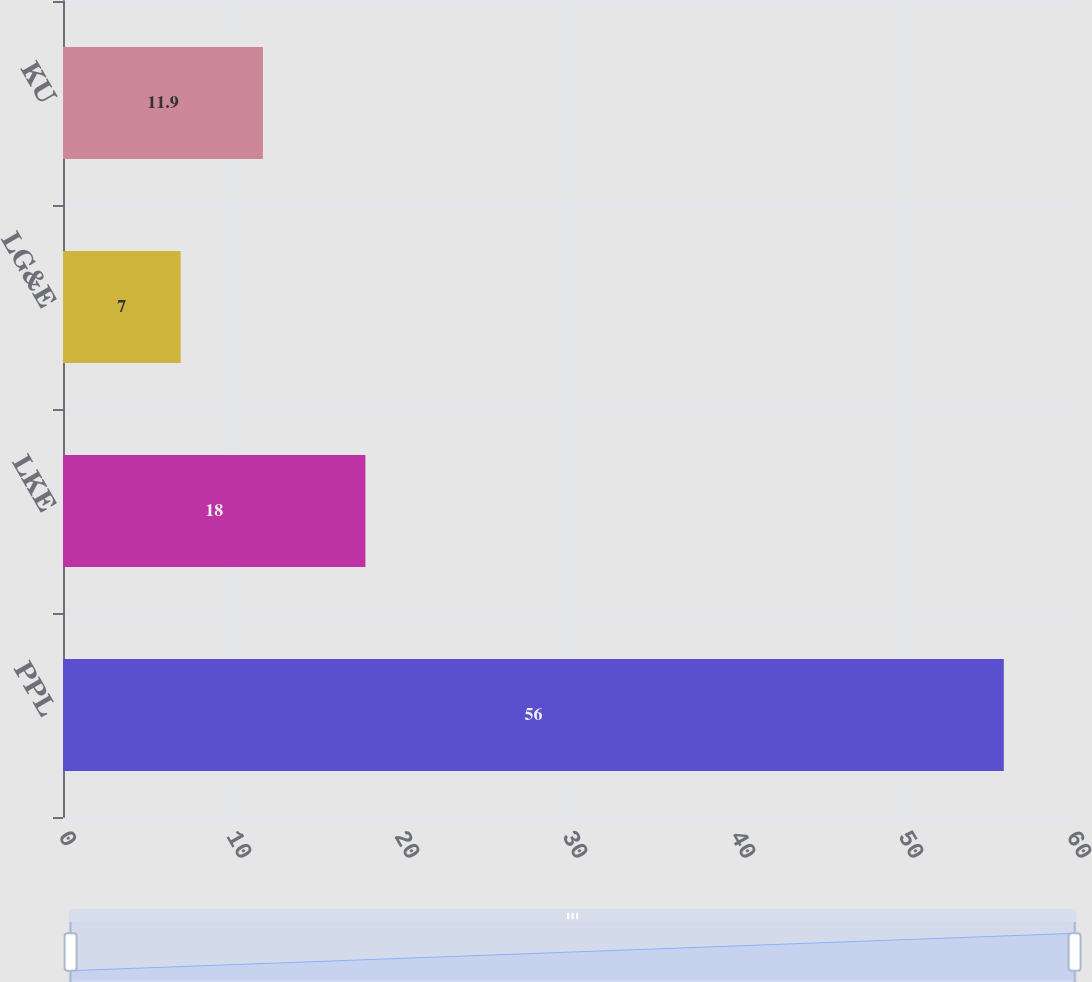Convert chart to OTSL. <chart><loc_0><loc_0><loc_500><loc_500><bar_chart><fcel>PPL<fcel>LKE<fcel>LG&E<fcel>KU<nl><fcel>56<fcel>18<fcel>7<fcel>11.9<nl></chart> 